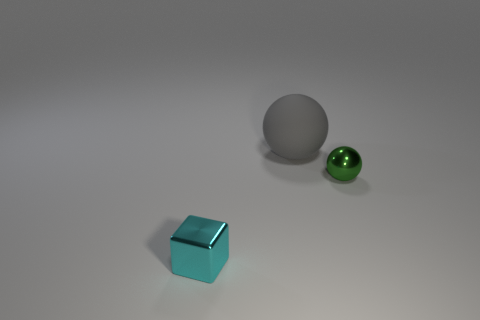There is a ball to the right of the large ball behind the small sphere; what color is it?
Your answer should be very brief. Green. Are there fewer cyan metal blocks that are in front of the large gray matte sphere than large matte spheres left of the tiny cyan metal thing?
Keep it short and to the point. No. What number of objects are large things that are left of the green metallic object or large brown metal cylinders?
Offer a very short reply. 1. There is a metal thing in front of the shiny sphere; is it the same size as the gray rubber sphere?
Make the answer very short. No. Are there fewer tiny green balls that are behind the large gray object than gray matte things?
Offer a terse response. Yes. There is a cyan cube that is the same size as the green sphere; what material is it?
Offer a terse response. Metal. What number of tiny things are spheres or metallic cubes?
Keep it short and to the point. 2. How many things are metallic things on the left side of the tiny green thing or small shiny things that are left of the green shiny thing?
Offer a terse response. 1. Is the number of cyan shiny blocks less than the number of metal cylinders?
Keep it short and to the point. No. There is a cyan thing that is the same size as the metal ball; what shape is it?
Provide a short and direct response. Cube. 